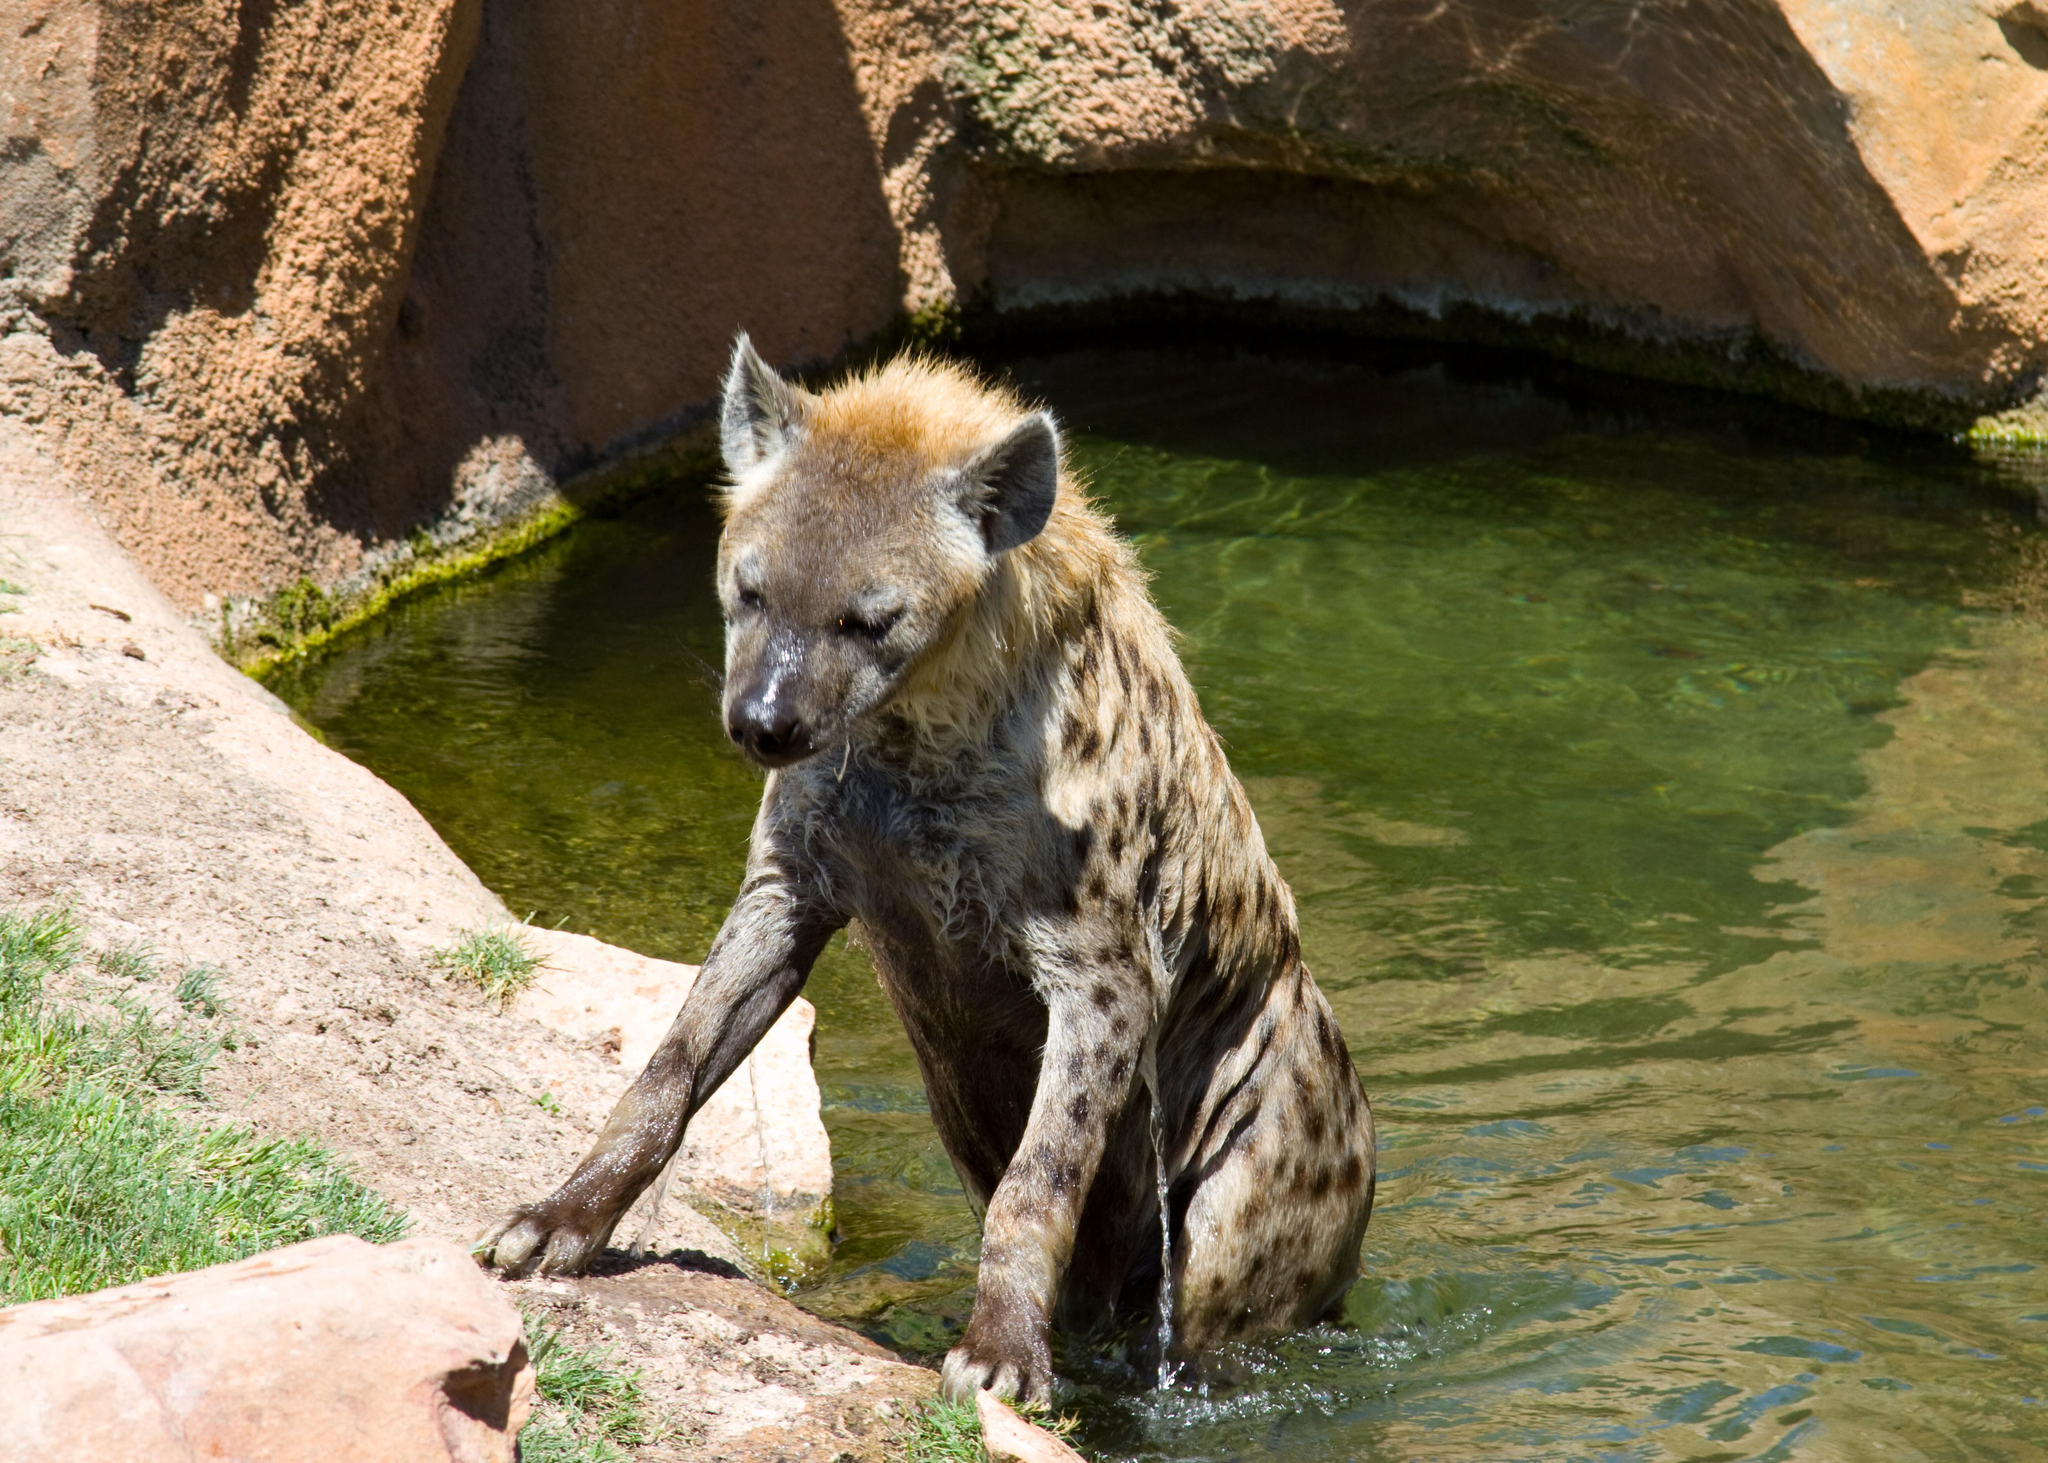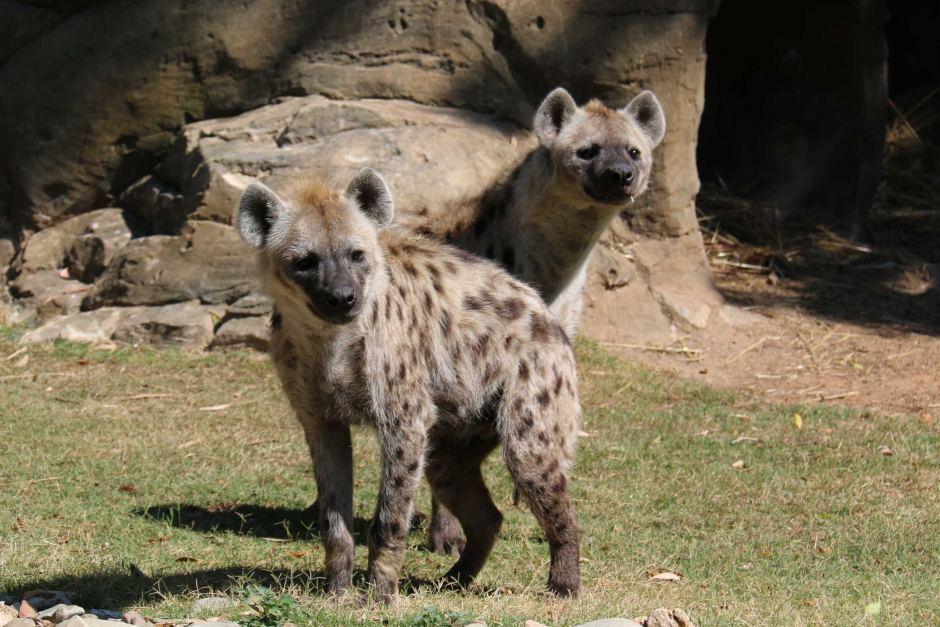The first image is the image on the left, the second image is the image on the right. Considering the images on both sides, is "A hyena is carrying something in its mouth." valid? Answer yes or no. No. The first image is the image on the left, the second image is the image on the right. Given the left and right images, does the statement "At least one hyena has its legs in water." hold true? Answer yes or no. Yes. 